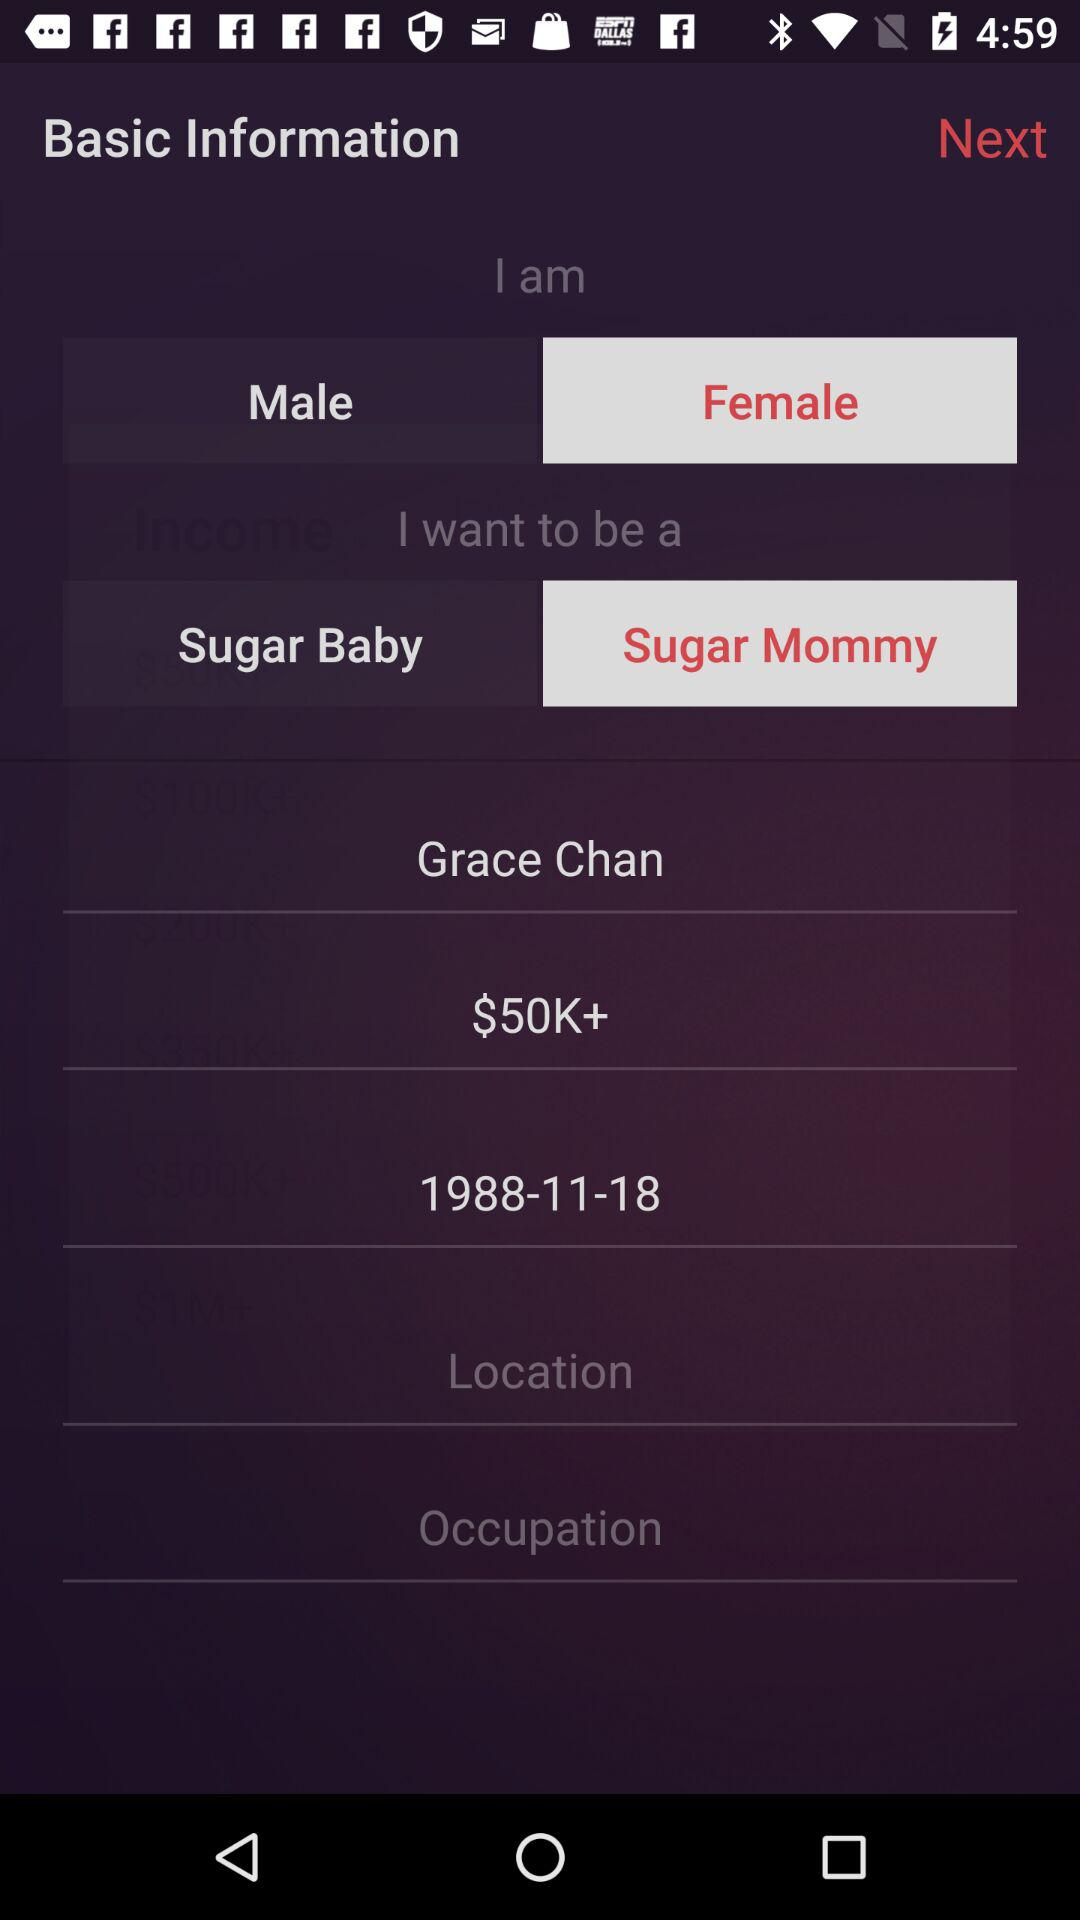What is the date of birth? The date of birth is November 18, 1988. 